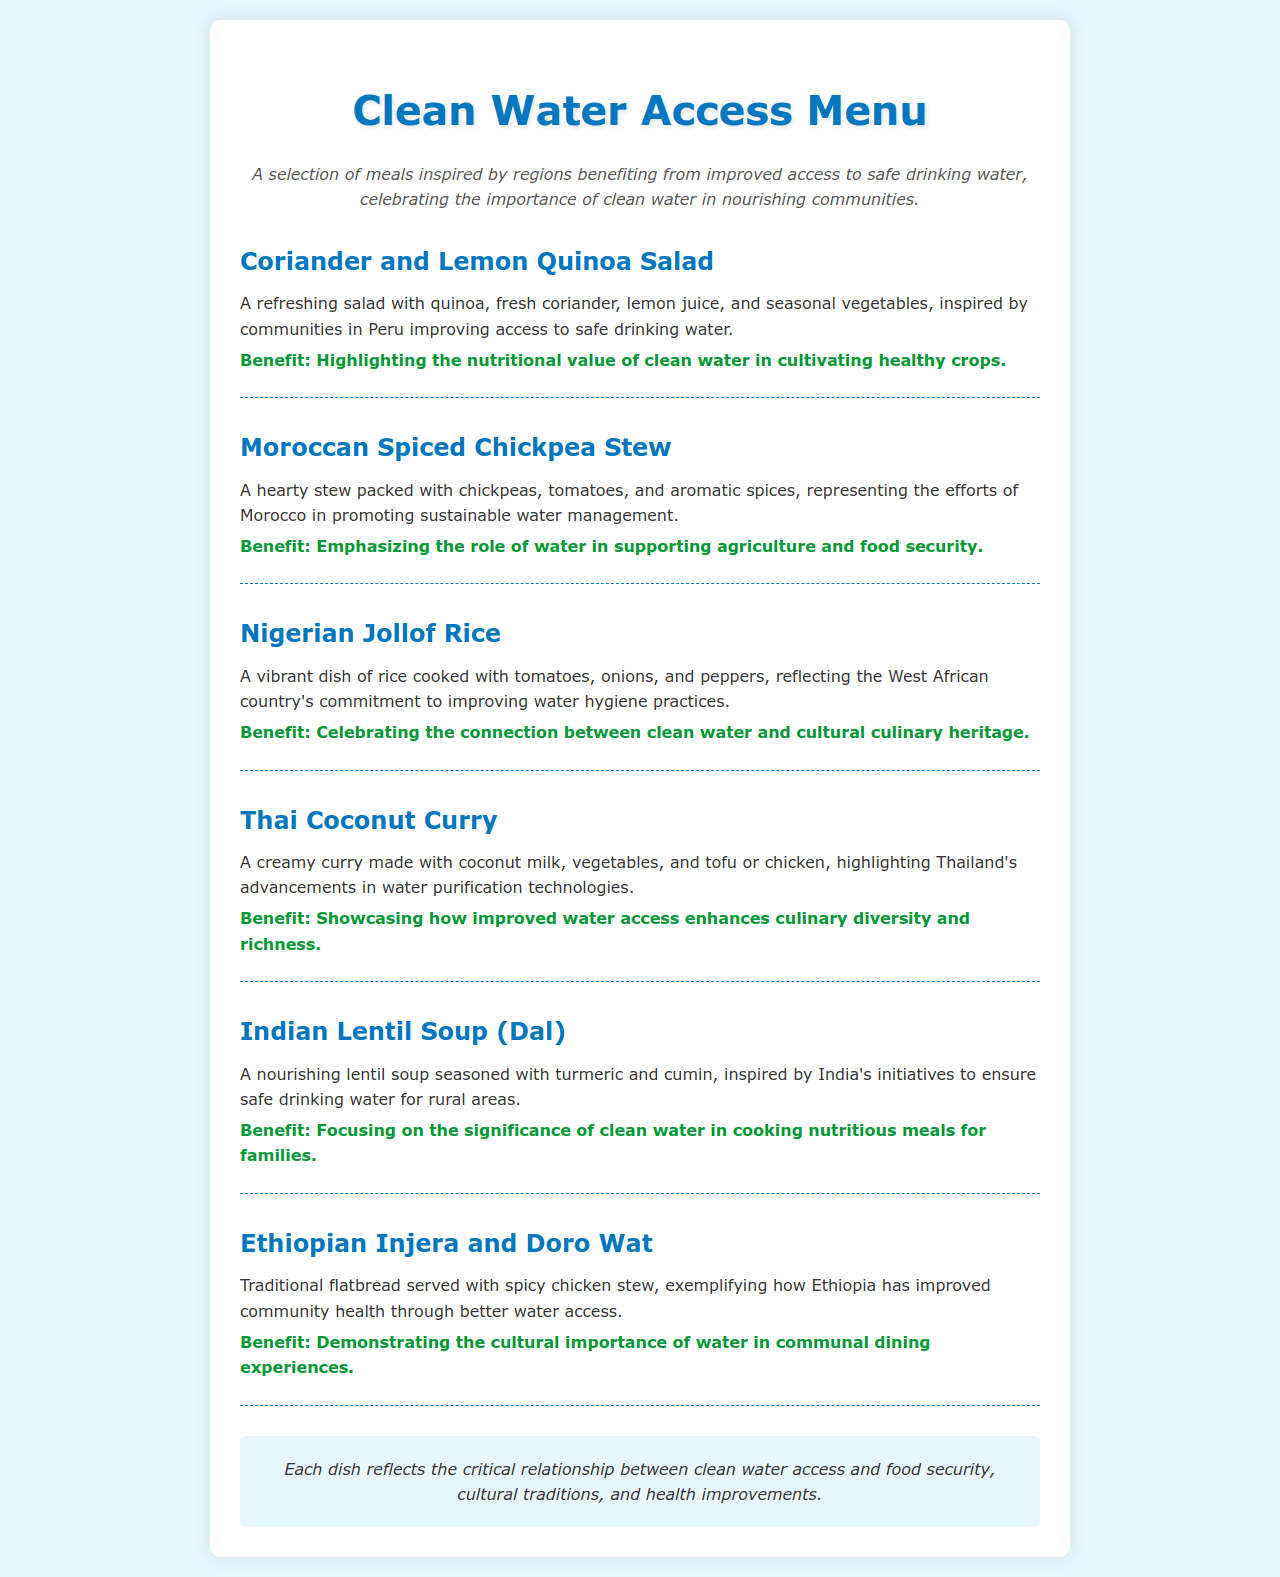What is the first menu item? The first menu item listed in the document is "Coriander and Lemon Quinoa Salad."
Answer: Coriander and Lemon Quinoa Salad Which country is associated with the Moroccan Spiced Chickpea Stew? The Moroccan Spiced Chickpea Stew is inspired by Morocco.
Answer: Morocco What type of dish is the Indian Lentil Soup? The Indian Lentil Soup is classified as a soup.
Answer: Soup How does improved water access relate to Thai Coconut Curry according to the document? The document highlights that improved water access enhances culinary diversity and richness, specifically for the Thai Coconut Curry.
Answer: Culinary diversity What is the overall theme of the Clean Water Access Menu? The overall theme emphasizes the critical relationship between clean water access and food security, cultural traditions, and health improvements.
Answer: Food security, cultural traditions, health improvements What specific benefit does the Nigerian Jollof Rice highlight? The benefit highlighted by the Nigerian Jollof Rice celebrates the connection between clean water and cultural culinary heritage.
Answer: Cultural culinary heritage 